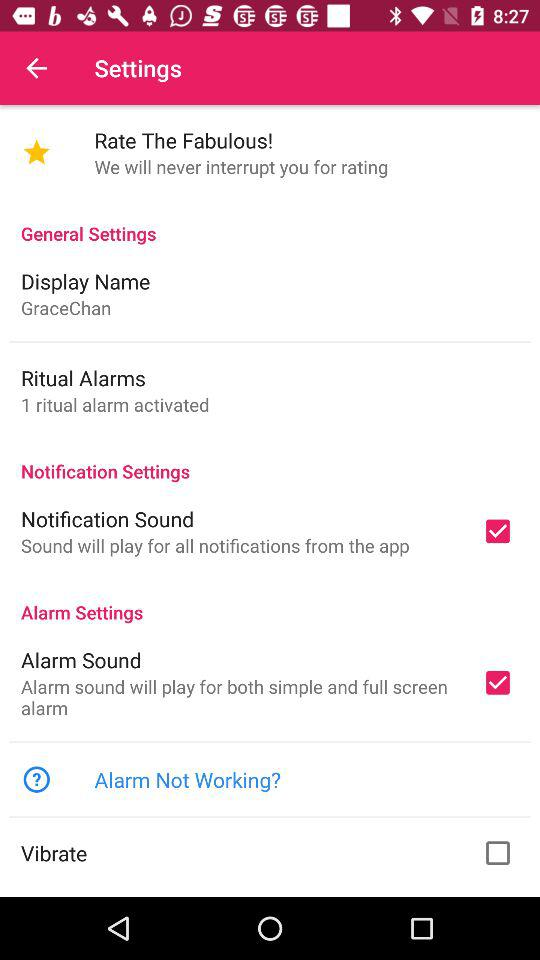What is the current status of "Vibrate"? The current status is "off". 